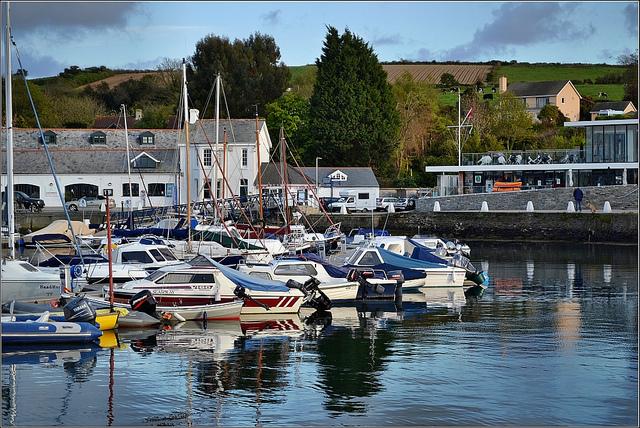Are there any people in this picture?
Be succinct. Yes. How many boats are there?
Quick response, please. 10. How many boats are in this picture?
Be succinct. 18. Do you see people swimming?
Be succinct. No. Are there boats in this picture?
Short answer required. Yes. What color is the house?
Short answer required. White. 